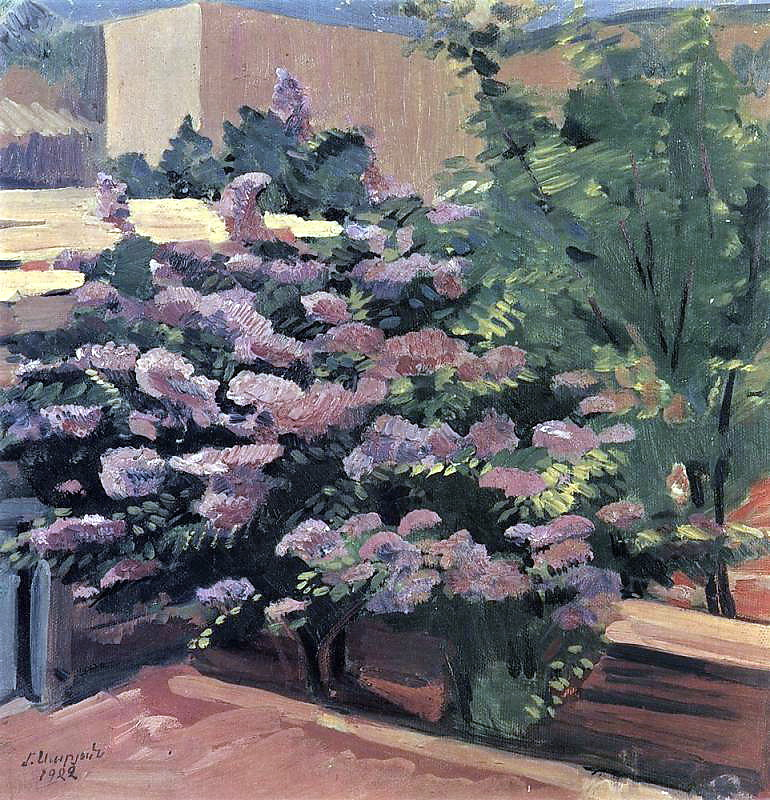Imagine this is the garden of a small cottage. Describe the cottage. The small cottage nestled in this garden would be a quaint and charming structure, with ivy-covered stone walls and a thatched roof. The windows are adorned with wooden shutters painted in a soft, pastel hue, and window boxes brimming with vibrant flowers that mirror the garden's blooms. A wooden door, slightly worn from years of use, invites visitors inside. Smoke gently curls from the chimney, suggesting a warm and cozy interior. Inside, the cottage is a haven of rustic comfort – wooden beams crisscross the ceiling, a large fireplace crackles with a welcoming fire, and every room is decorated with a mix of vintage and handcrafted furniture, soft cushions, and colorful rugs that add to the homely and inviting ambiance. 